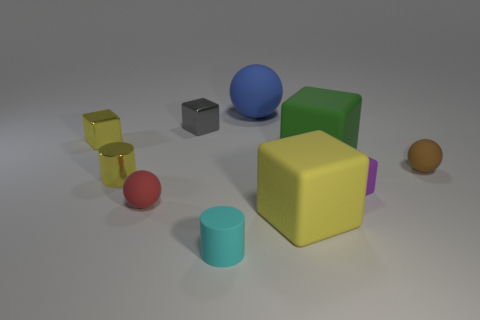Can you comment on the lighting and shadows in the scene? The objects are lit by a diffuse light source, given away by the soft shadows under each object. There is no harsh direct light, resulting in gentle shadow gradients, which provide a sense of depth and dimension to the scene. The directionality of the shadows suggests a single light source coming from the upper left, as demonstrated by the longer shadows cast towards the bottom right.  Do the shadows give us any information about the shape of the objects? Absolutely. The shadows affirm the three-dimensionality of the objects. For example, the shadow of the yellow block is a rectangle, consistent with its cubic form. Similarly, the round shadows of the spheres and cylinders help reinforce their curved surfaces. The softness and angle of the shadows give us clues about the objects' relative sizes and the distance between them. 